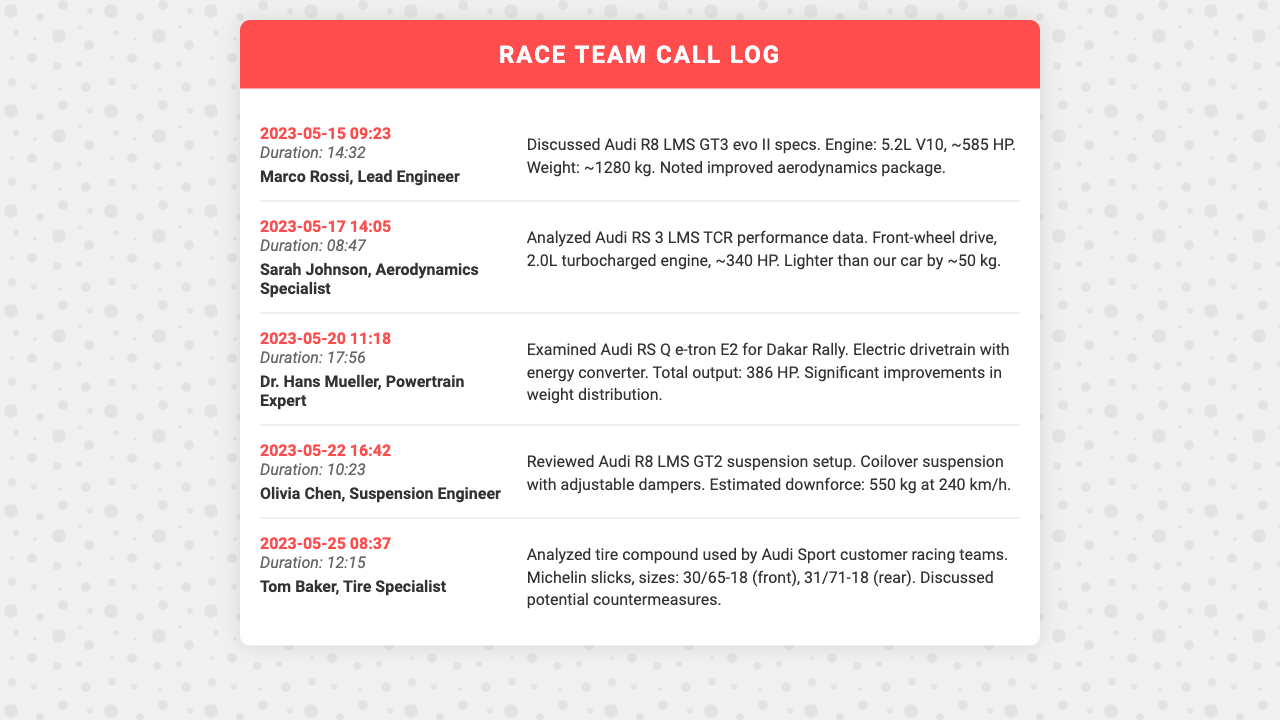What is the date of the first call? The date of the first call is noted at the beginning of the log, which is 2023-05-15.
Answer: 2023-05-15 Who did the second call involve? The second call's contact is mentioned directly in the entry, which is Sarah Johnson.
Answer: Sarah Johnson What was discussed in the third call? The call notes specify the topics discussed during the call, which pertained to Audi RS Q e-tron E2 for Dakar Rally.
Answer: Audi RS Q e-tron E2 for Dakar Rally How long was the call with Marco Rossi? The duration of the call with Marco Rossi is provided in the call entry details, which is 14 minutes and 32 seconds.
Answer: 14:32 What type of suspension does the Audi R8 LMS GT2 use? The notes specify that the suspension setup involves coilover suspension with adjustable dampers.
Answer: Coilover suspension Which Audi model has a 5.2L V10 engine? The specifications listed in the first call indicate that the Audi R8 LMS GT3 evo II has a 5.2L V10 engine.
Answer: Audi R8 LMS GT3 evo II What was the total horsepower of the Audi RS Q e-tron E2? The call notes directly indicate that the total output is 386 HP for the Audi RS Q e-tron E2.
Answer: 386 HP How many calls were made in total? The number of call entries indicates the total calls made, which is five in total.
Answer: 5 What are the tire sizes mentioned in the call with Tom Baker? The notes provide specific tire sizes used by Audi Sport customer racing teams, which are 30/65-18 and 31/71-18.
Answer: 30/65-18, 31/71-18 